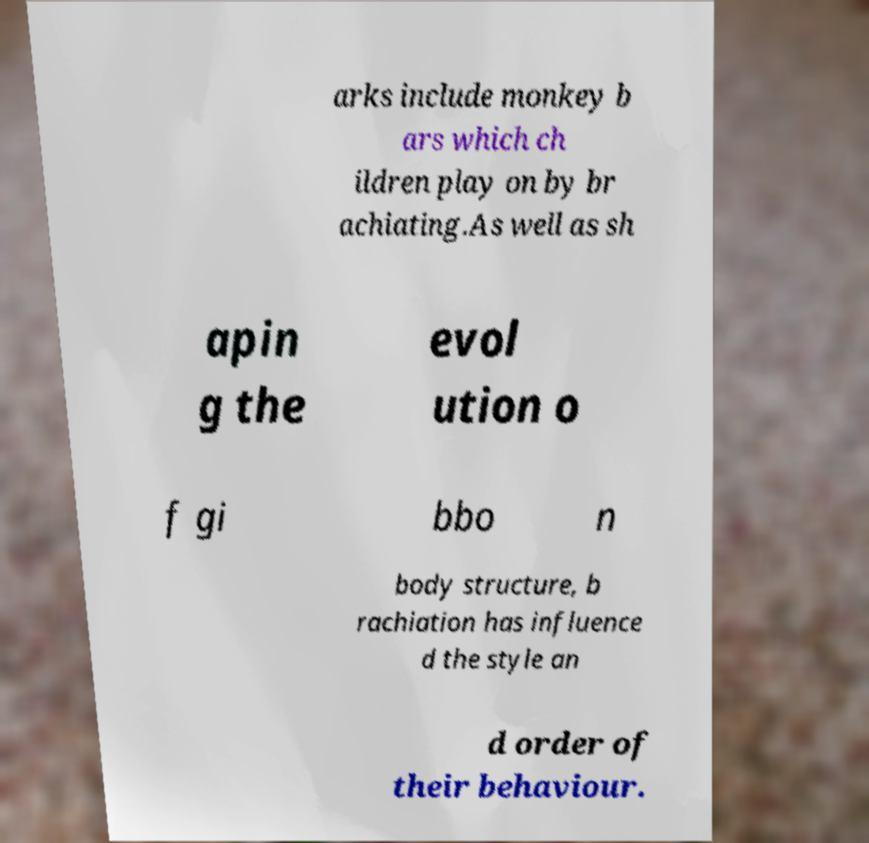Can you accurately transcribe the text from the provided image for me? arks include monkey b ars which ch ildren play on by br achiating.As well as sh apin g the evol ution o f gi bbo n body structure, b rachiation has influence d the style an d order of their behaviour. 